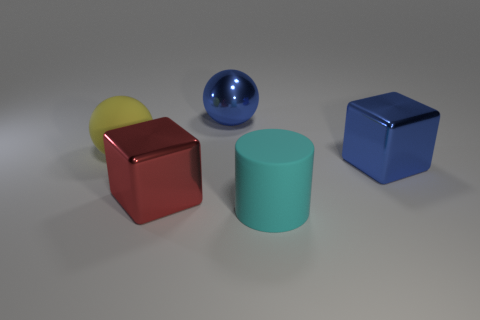Are there any other things that are the same shape as the large cyan rubber thing?
Keep it short and to the point. No. Is the shape of the large yellow rubber object the same as the cyan object?
Your response must be concise. No. Are there any cyan matte cylinders that are behind the big blue object behind the big block that is right of the cyan rubber thing?
Ensure brevity in your answer.  No. What number of other objects are the same color as the large cylinder?
Give a very brief answer. 0. Is the number of large blue metallic cubes behind the metallic sphere the same as the number of red cubes that are in front of the large cyan rubber thing?
Offer a terse response. Yes. There is a yellow object; does it have the same size as the shiny cube on the right side of the red cube?
Provide a short and direct response. Yes. What is the material of the big thing on the right side of the big rubber thing that is right of the large yellow rubber object?
Your response must be concise. Metal. Are there the same number of matte objects to the left of the metallic ball and yellow spheres?
Offer a terse response. Yes. There is a shiny thing that is both to the left of the large cyan rubber cylinder and in front of the blue sphere; how big is it?
Your answer should be very brief. Large. What is the color of the object that is in front of the block that is to the left of the big matte cylinder?
Ensure brevity in your answer.  Cyan. 